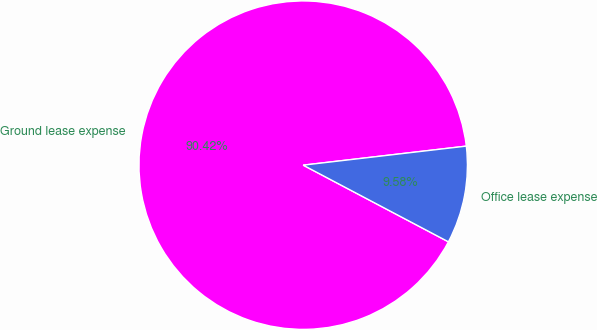Convert chart. <chart><loc_0><loc_0><loc_500><loc_500><pie_chart><fcel>Ground lease expense<fcel>Office lease expense<nl><fcel>90.42%<fcel>9.58%<nl></chart> 